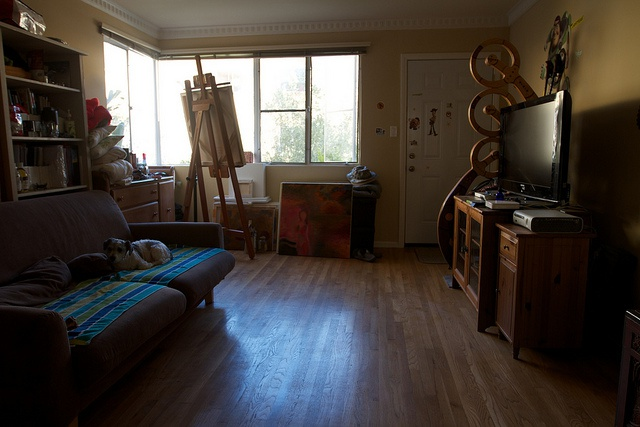Describe the objects in this image and their specific colors. I can see couch in black, darkblue, blue, and gray tones, tv in black, gray, and darkgray tones, and dog in black and gray tones in this image. 